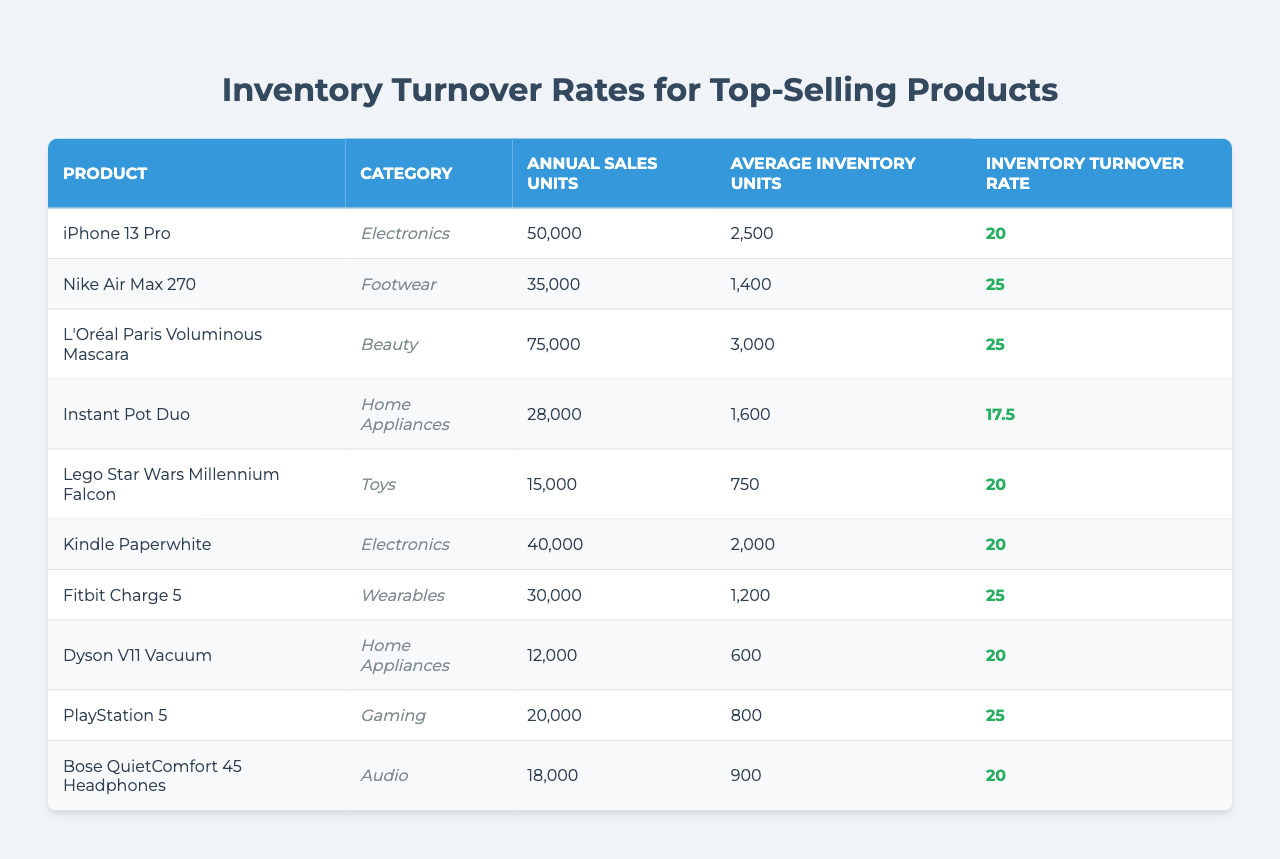What's the product with the highest inventory turnover rate? The table shows the turnover rates for each product. Scanning the "Inventory Turnover Rate" column, the highest value is for "Nike Air Max 270" with a rate of 25.
Answer: Nike Air Max 270 How many annual sales units does the "Kindle Paperwhite" have? In the table, the row for "Kindle Paperwhite" lists its annual sales units under the "Annual Sales Units" column, which shows 40,000.
Answer: 40,000 Which product has the lowest inventory turnover rate? Looking at the "Inventory Turnover Rate" column, the product with the lowest turnover rate is "Instant Pot Duo," which has a rate of 17.5.
Answer: Instant Pot Duo What is the average inventory turnover rate of all products listed? To find the average, sum the turnover rates: 20 + 25 + 25 + 17.5 + 20 + 20 + 25 + 20 + 25 + 20 =  225. Divide by the number of products (10): 225 / 10 = 22.5.
Answer: 22.5 Are there more electronics products or footwear products? By counting, we see that there are 3 electronics products ("iPhone 13 Pro," "Kindle Paperwhite," and "Dyson V11 Vacuum") and 1 footwear product ("Nike Air Max 270"). Since 3 is greater than 1, there are more electronics products.
Answer: Yes Which product belongs to the "Home Appliances" category and what is its turnover rate? The table shows that "Instant Pot Duo" and "Dyson V11 Vacuum" belong to "Home Appliances." Checking their turnover rates, "Instant Pot Duo" has 17.5 and "Dyson V11 Vacuum" has 20.
Answer: Instant Pot Duo has 17.5 and Dyson V11 has 20 If we combine the annual sales units of "L'Oréal Paris Voluminous Mascara" and "Fitbit Charge 5", what is the total? The annual sales units for "L'Oréal Paris Voluminous Mascara" is 75,000, and for "Fitbit Charge 5" it is 30,000. Adding these together: 75,000 + 30,000 = 105,000.
Answer: 105,000 What category does the product with the highest turnover rate belong to? The product with the highest turnover rate is "Nike Air Max 270," and looking at the category column, it belongs to "Footwear."
Answer: Footwear Are there any products with a turnover rate of 20? To find products with a turnover rate of 20, we check the "Inventory Turnover Rate" column. "iPhone 13 Pro," "Kindle Paperwhite," "Lego Star Wars Millennium Falcon," "Dyson V11 Vacuum," and "Bose QuietComfort 45 Headphones" all have a turnover rate of 20.
Answer: Yes 